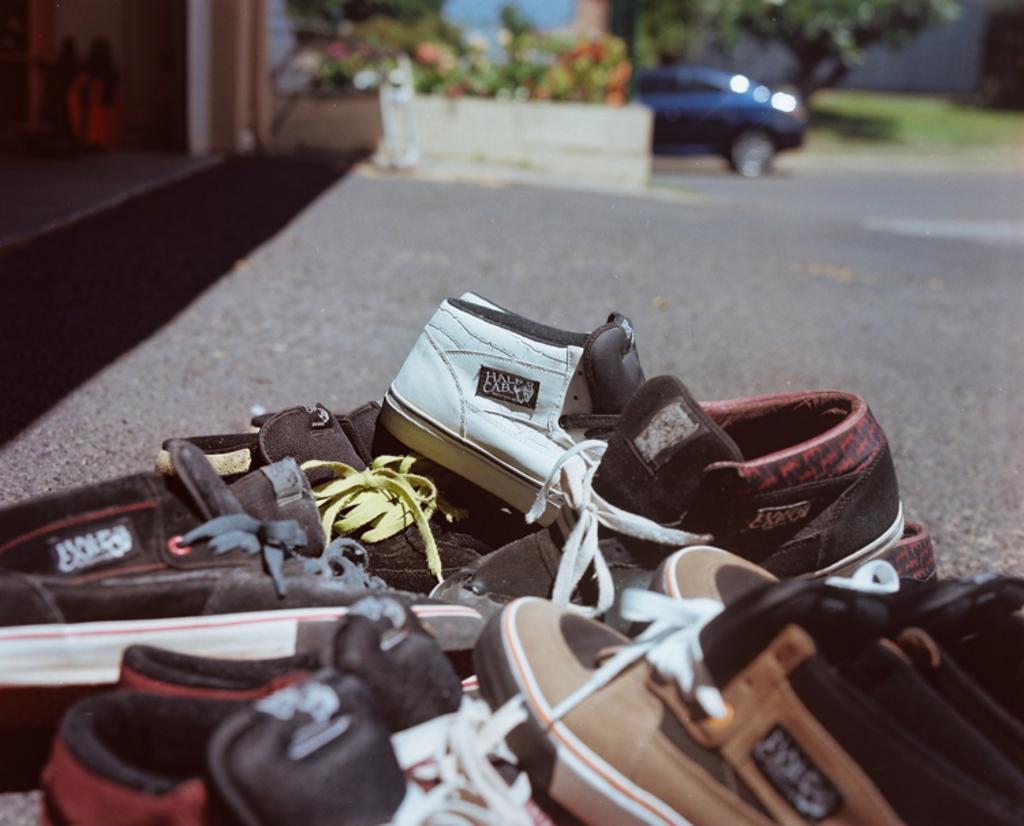Can you describe this image briefly? There are many shoes on the ground. In the back it is blurred. Also there is a car and trees. 